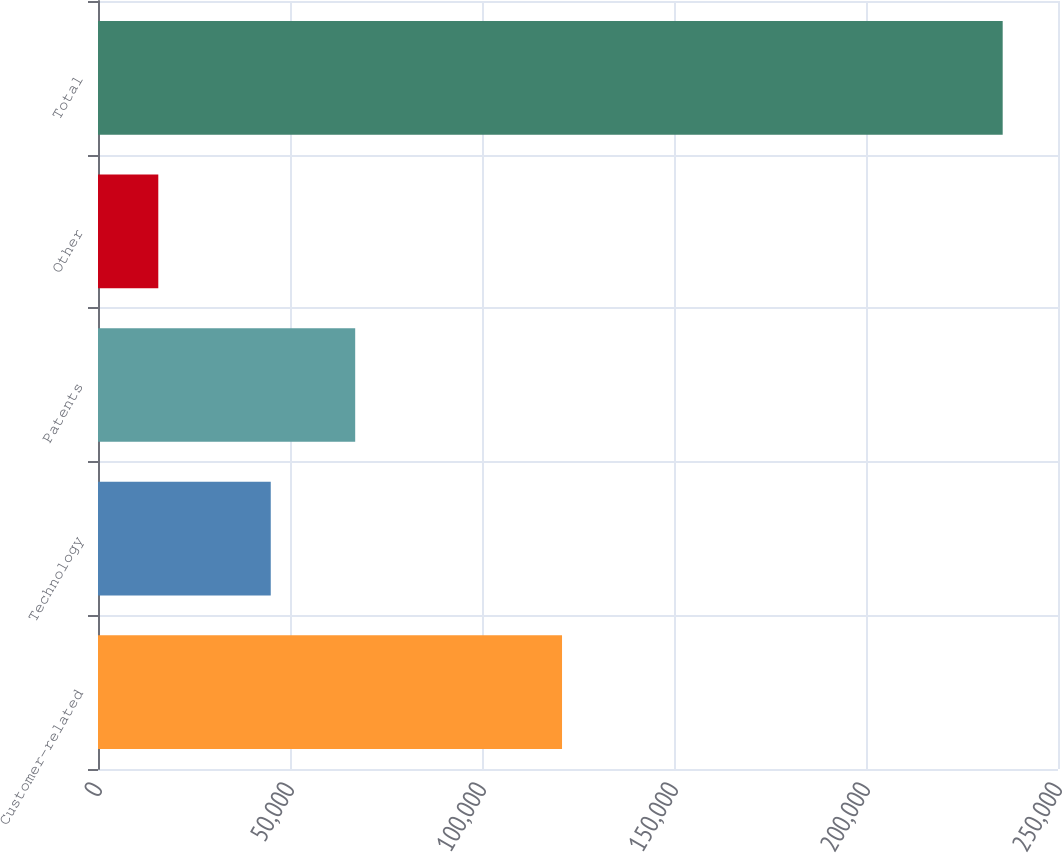Convert chart. <chart><loc_0><loc_0><loc_500><loc_500><bar_chart><fcel>Customer-related<fcel>Technology<fcel>Patents<fcel>Other<fcel>Total<nl><fcel>120841<fcel>44988<fcel>66977.3<fcel>15702<fcel>235595<nl></chart> 